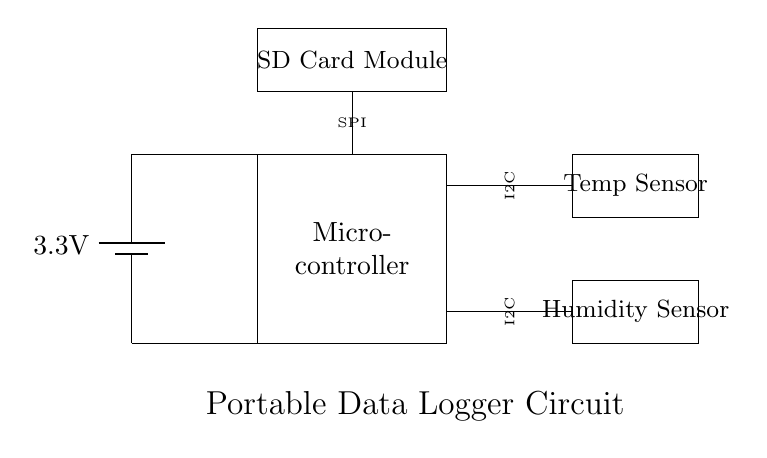What is the voltage supplied to the circuit? The voltage is supplied by a battery labeled as 3.3 volts, which is clearly indicated in the circuit diagram.
Answer: 3.3 volts What type of sensors are used in this circuit? The circuit includes a temperature sensor and a humidity sensor, both of which are represented by rectangles in the diagram with their labels.
Answer: Temperature sensor and humidity sensor How is the data transferred from the sensors to the microcontroller? The temperature and humidity sensors are connected to the microcontroller using the I2C communication protocol, which is labeled next to the respective sensors.
Answer: I2C What module is used for data storage in this circuit? The SD card module is included in the circuit, specifically labeled and located at the top, indicating its role for data storage.
Answer: SD card module How many main components are visible in the circuit diagram? By counting the components labeled in the circuit, we find a battery, microcontroller, two sensors, and an SD card module, totaling five distinct main components.
Answer: Five What type of communication protocol does the SD card module use? The SD card module is connected to the microcontroller using the SPI communication protocol, which is labeled next to the module in the diagram.
Answer: SPI 